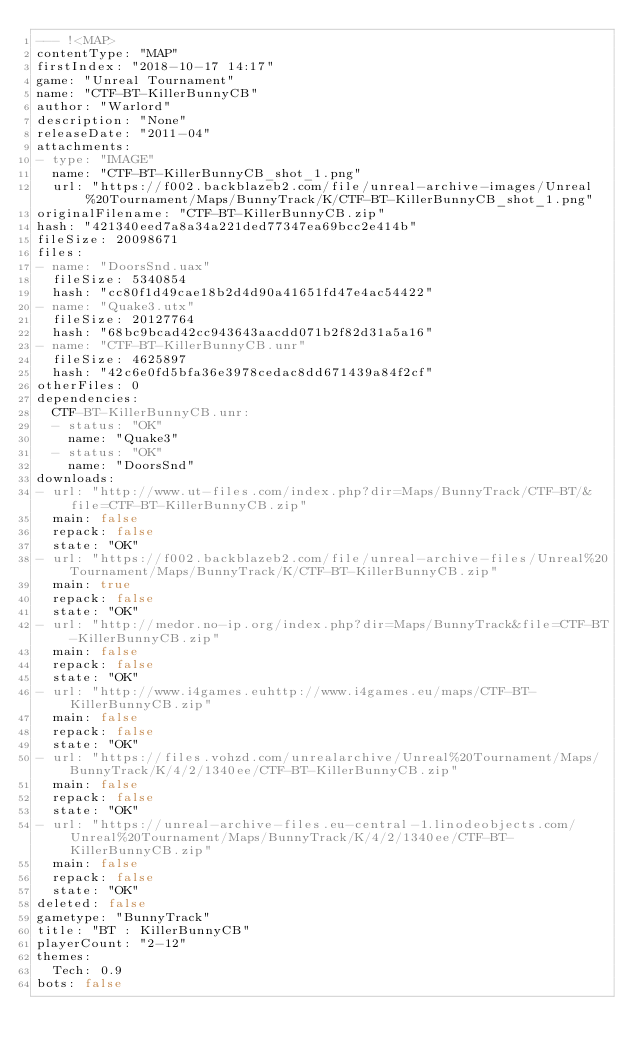<code> <loc_0><loc_0><loc_500><loc_500><_YAML_>--- !<MAP>
contentType: "MAP"
firstIndex: "2018-10-17 14:17"
game: "Unreal Tournament"
name: "CTF-BT-KillerBunnyCB"
author: "Warlord"
description: "None"
releaseDate: "2011-04"
attachments:
- type: "IMAGE"
  name: "CTF-BT-KillerBunnyCB_shot_1.png"
  url: "https://f002.backblazeb2.com/file/unreal-archive-images/Unreal%20Tournament/Maps/BunnyTrack/K/CTF-BT-KillerBunnyCB_shot_1.png"
originalFilename: "CTF-BT-KillerBunnyCB.zip"
hash: "421340eed7a8a34a221ded77347ea69bcc2e414b"
fileSize: 20098671
files:
- name: "DoorsSnd.uax"
  fileSize: 5340854
  hash: "cc80f1d49cae18b2d4d90a41651fd47e4ac54422"
- name: "Quake3.utx"
  fileSize: 20127764
  hash: "68bc9bcad42cc943643aacdd071b2f82d31a5a16"
- name: "CTF-BT-KillerBunnyCB.unr"
  fileSize: 4625897
  hash: "42c6e0fd5bfa36e3978cedac8dd671439a84f2cf"
otherFiles: 0
dependencies:
  CTF-BT-KillerBunnyCB.unr:
  - status: "OK"
    name: "Quake3"
  - status: "OK"
    name: "DoorsSnd"
downloads:
- url: "http://www.ut-files.com/index.php?dir=Maps/BunnyTrack/CTF-BT/&file=CTF-BT-KillerBunnyCB.zip"
  main: false
  repack: false
  state: "OK"
- url: "https://f002.backblazeb2.com/file/unreal-archive-files/Unreal%20Tournament/Maps/BunnyTrack/K/CTF-BT-KillerBunnyCB.zip"
  main: true
  repack: false
  state: "OK"
- url: "http://medor.no-ip.org/index.php?dir=Maps/BunnyTrack&file=CTF-BT-KillerBunnyCB.zip"
  main: false
  repack: false
  state: "OK"
- url: "http://www.i4games.euhttp://www.i4games.eu/maps/CTF-BT-KillerBunnyCB.zip"
  main: false
  repack: false
  state: "OK"
- url: "https://files.vohzd.com/unrealarchive/Unreal%20Tournament/Maps/BunnyTrack/K/4/2/1340ee/CTF-BT-KillerBunnyCB.zip"
  main: false
  repack: false
  state: "OK"
- url: "https://unreal-archive-files.eu-central-1.linodeobjects.com/Unreal%20Tournament/Maps/BunnyTrack/K/4/2/1340ee/CTF-BT-KillerBunnyCB.zip"
  main: false
  repack: false
  state: "OK"
deleted: false
gametype: "BunnyTrack"
title: "BT : KillerBunnyCB"
playerCount: "2-12"
themes:
  Tech: 0.9
bots: false
</code> 